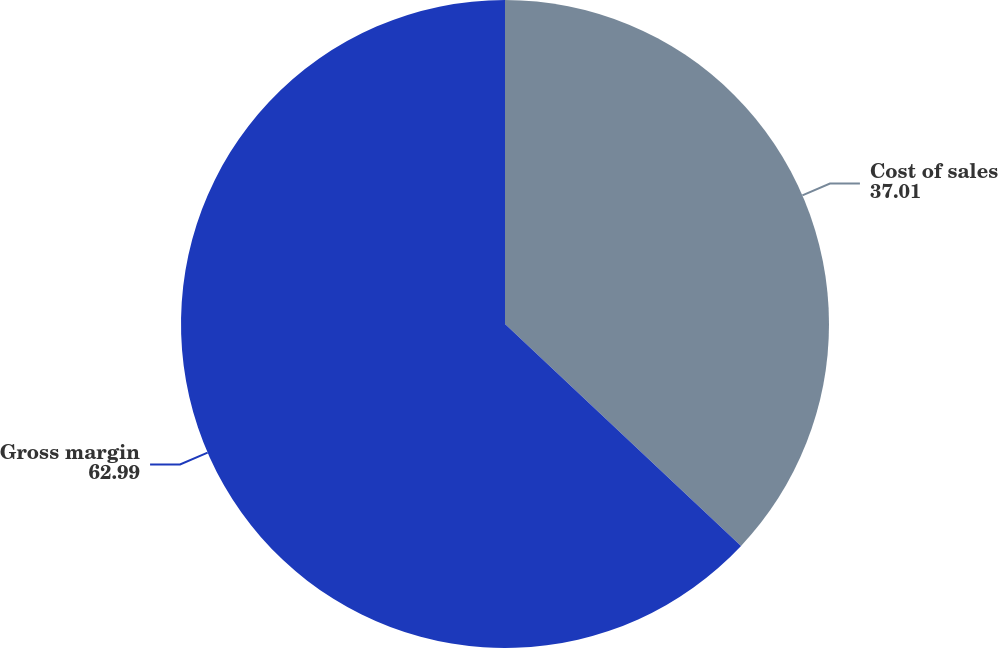<chart> <loc_0><loc_0><loc_500><loc_500><pie_chart><fcel>Cost of sales<fcel>Gross margin<nl><fcel>37.01%<fcel>62.99%<nl></chart> 